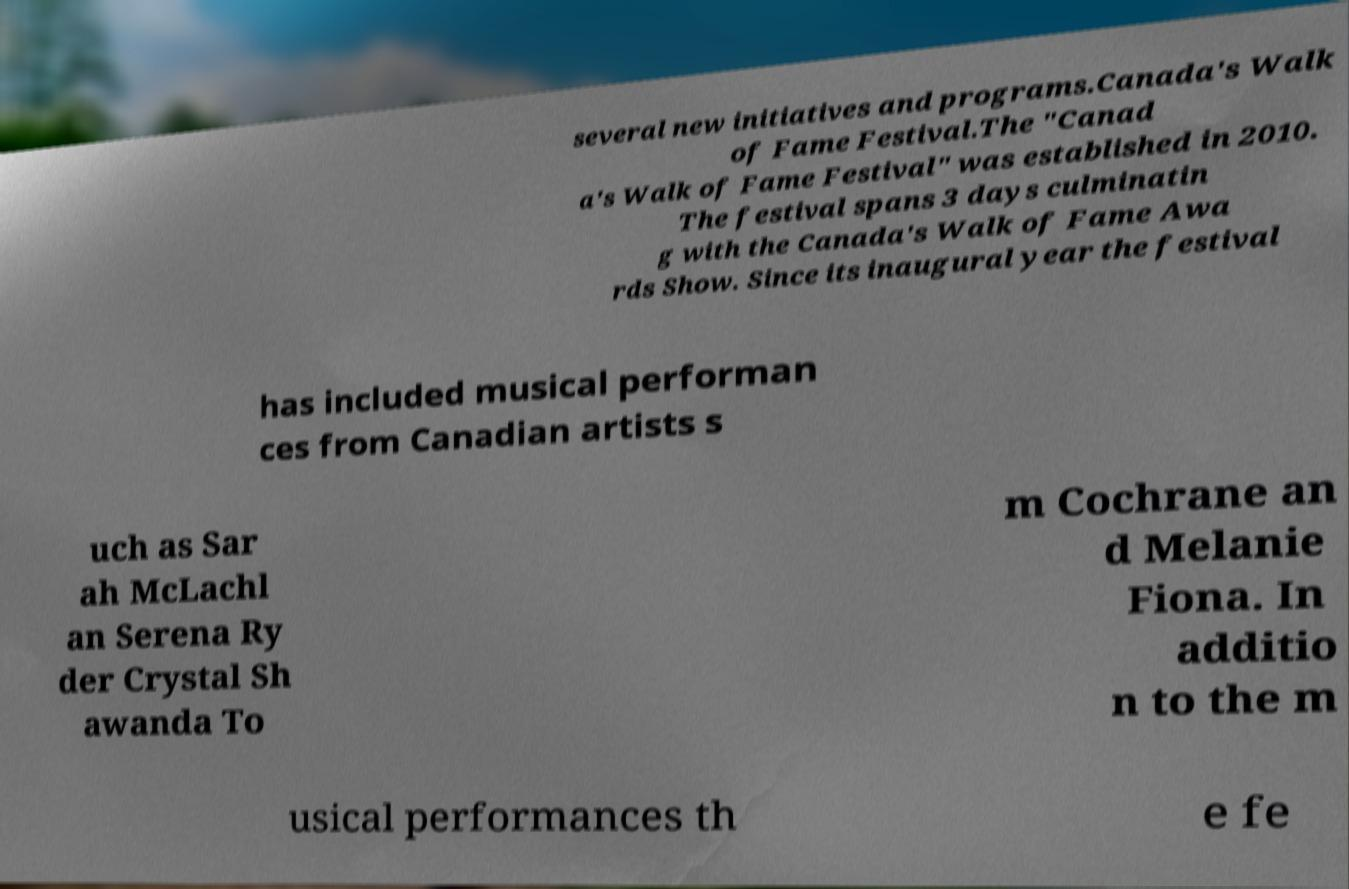There's text embedded in this image that I need extracted. Can you transcribe it verbatim? several new initiatives and programs.Canada's Walk of Fame Festival.The "Canad a's Walk of Fame Festival" was established in 2010. The festival spans 3 days culminatin g with the Canada's Walk of Fame Awa rds Show. Since its inaugural year the festival has included musical performan ces from Canadian artists s uch as Sar ah McLachl an Serena Ry der Crystal Sh awanda To m Cochrane an d Melanie Fiona. In additio n to the m usical performances th e fe 